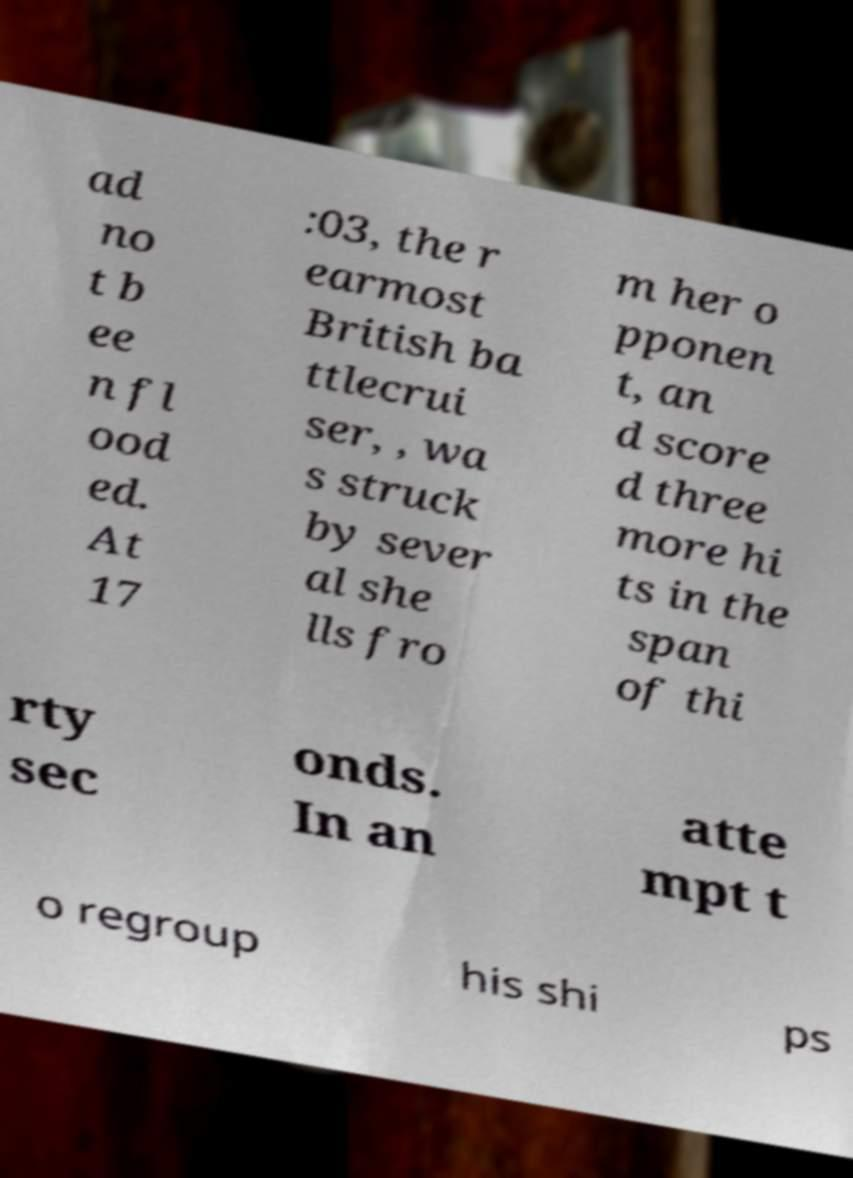For documentation purposes, I need the text within this image transcribed. Could you provide that? ad no t b ee n fl ood ed. At 17 :03, the r earmost British ba ttlecrui ser, , wa s struck by sever al she lls fro m her o pponen t, an d score d three more hi ts in the span of thi rty sec onds. In an atte mpt t o regroup his shi ps 